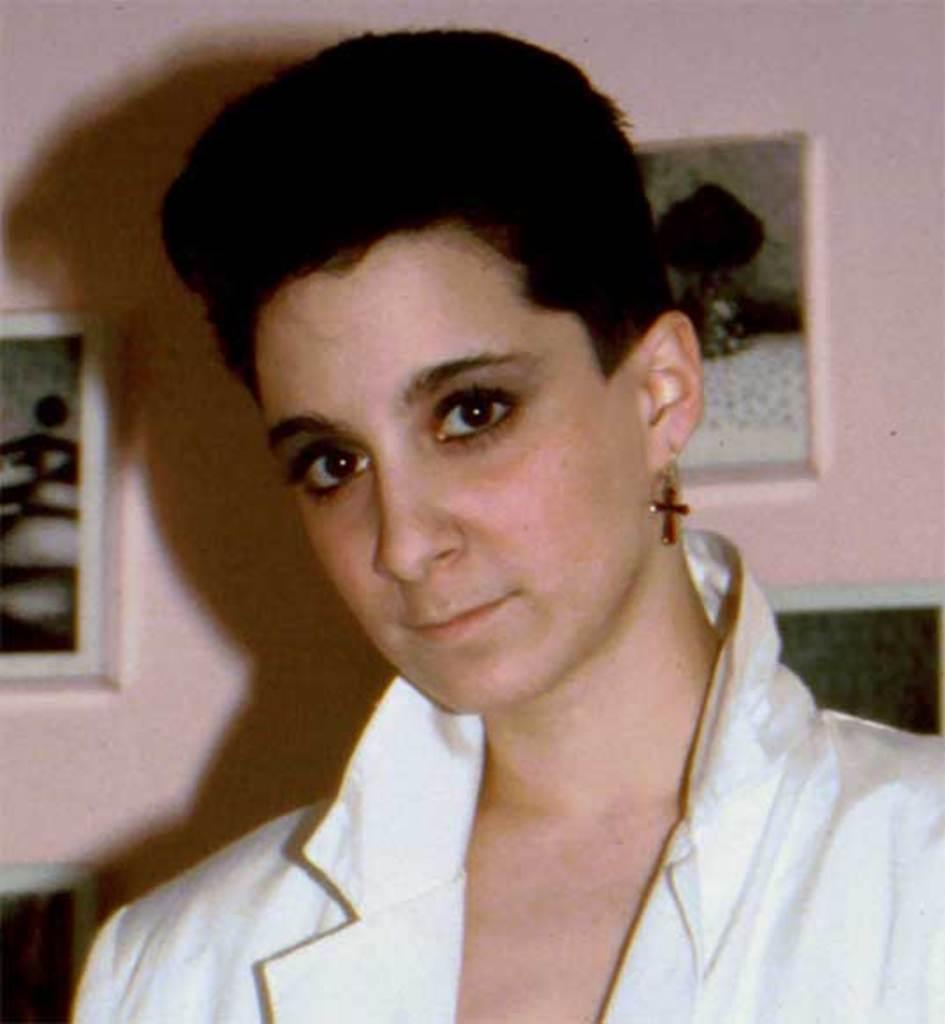Please provide a concise description of this image. In this picture I can see a woman in front and I see that she is wearing white color dress. In the background I see the wall, on which I see a photo frame on the left side of this image and I see a thing on the right side of this image. 